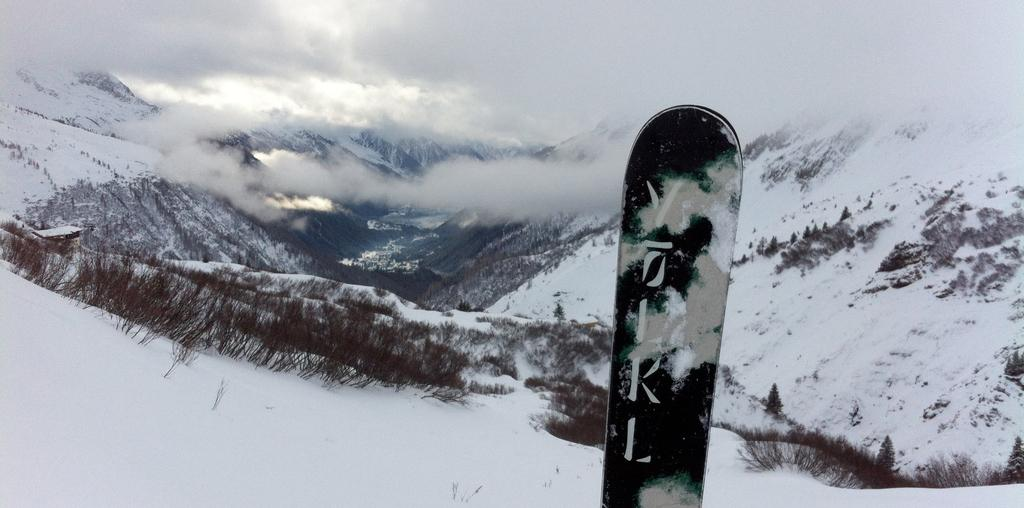Where was the image taken? The image was taken on a snow hill. What is the main object in the center of the image? There is a board in the center of the image. What can be seen in the background of the image? Hills covered with snow and plants are visible in the background, along with fog. How many passengers are visible on the board in the image? There are no passengers visible on the board in the image; it is the only object in the center of the image. 